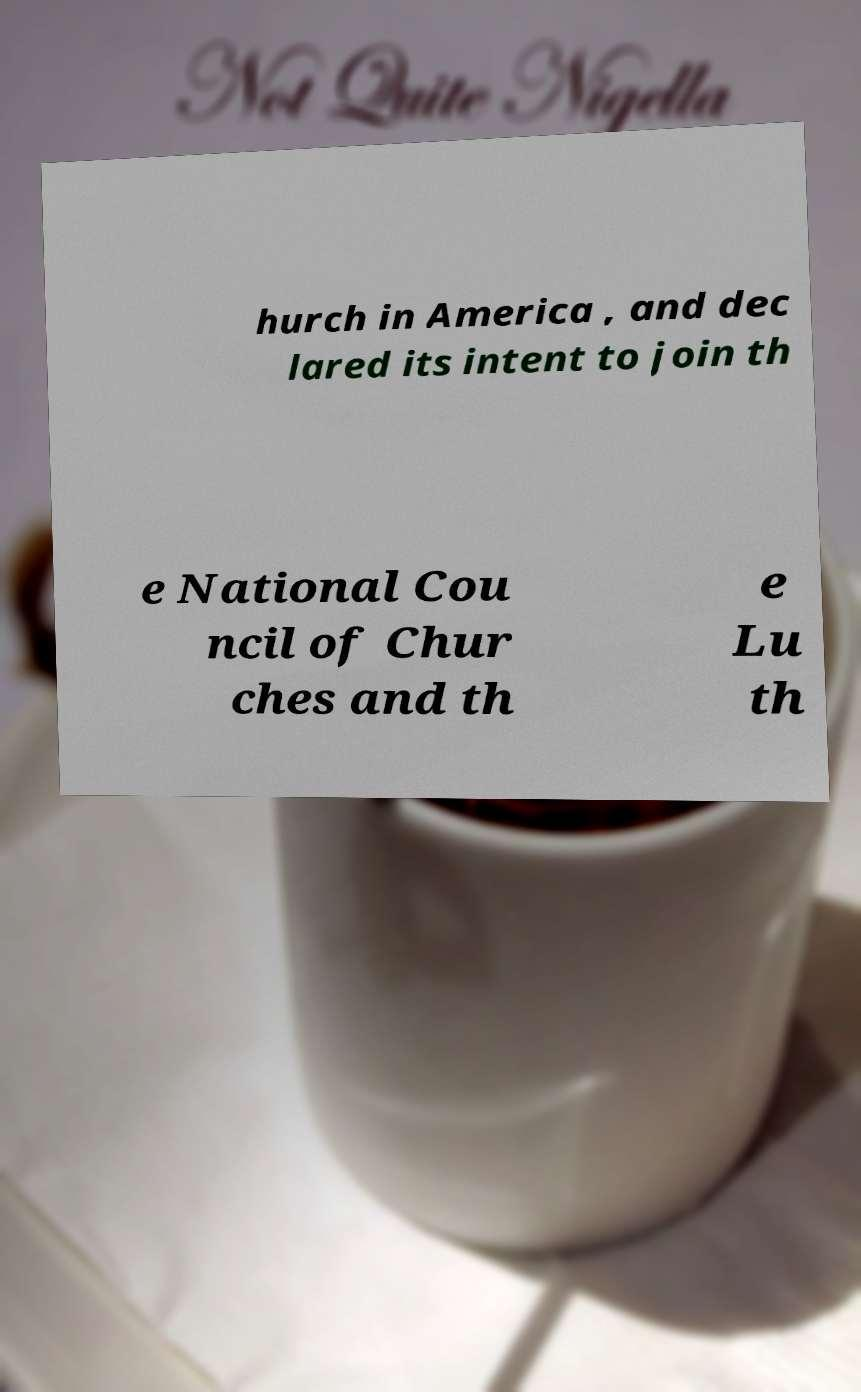Can you accurately transcribe the text from the provided image for me? hurch in America , and dec lared its intent to join th e National Cou ncil of Chur ches and th e Lu th 